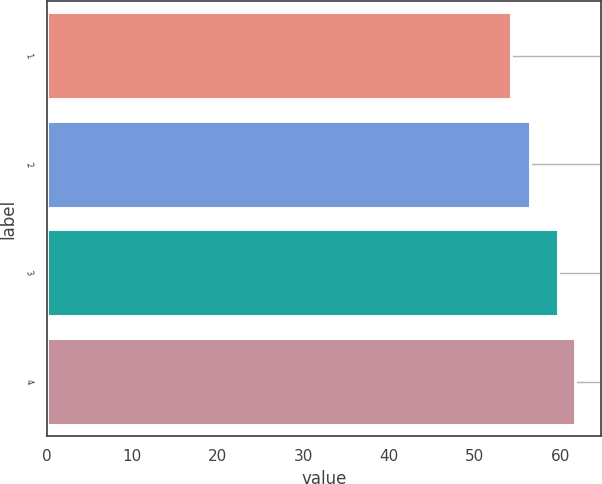Convert chart. <chart><loc_0><loc_0><loc_500><loc_500><bar_chart><fcel>1<fcel>2<fcel>3<fcel>4<nl><fcel>54.25<fcel>56.43<fcel>59.75<fcel>61.68<nl></chart> 